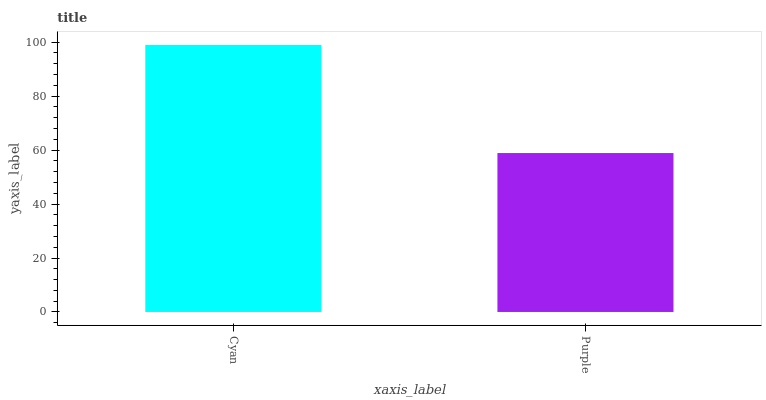Is Purple the minimum?
Answer yes or no. Yes. Is Cyan the maximum?
Answer yes or no. Yes. Is Purple the maximum?
Answer yes or no. No. Is Cyan greater than Purple?
Answer yes or no. Yes. Is Purple less than Cyan?
Answer yes or no. Yes. Is Purple greater than Cyan?
Answer yes or no. No. Is Cyan less than Purple?
Answer yes or no. No. Is Cyan the high median?
Answer yes or no. Yes. Is Purple the low median?
Answer yes or no. Yes. Is Purple the high median?
Answer yes or no. No. Is Cyan the low median?
Answer yes or no. No. 